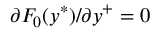<formula> <loc_0><loc_0><loc_500><loc_500>\partial F _ { 0 } ( y ^ { \ast } ) / \partial y ^ { + } = 0</formula> 